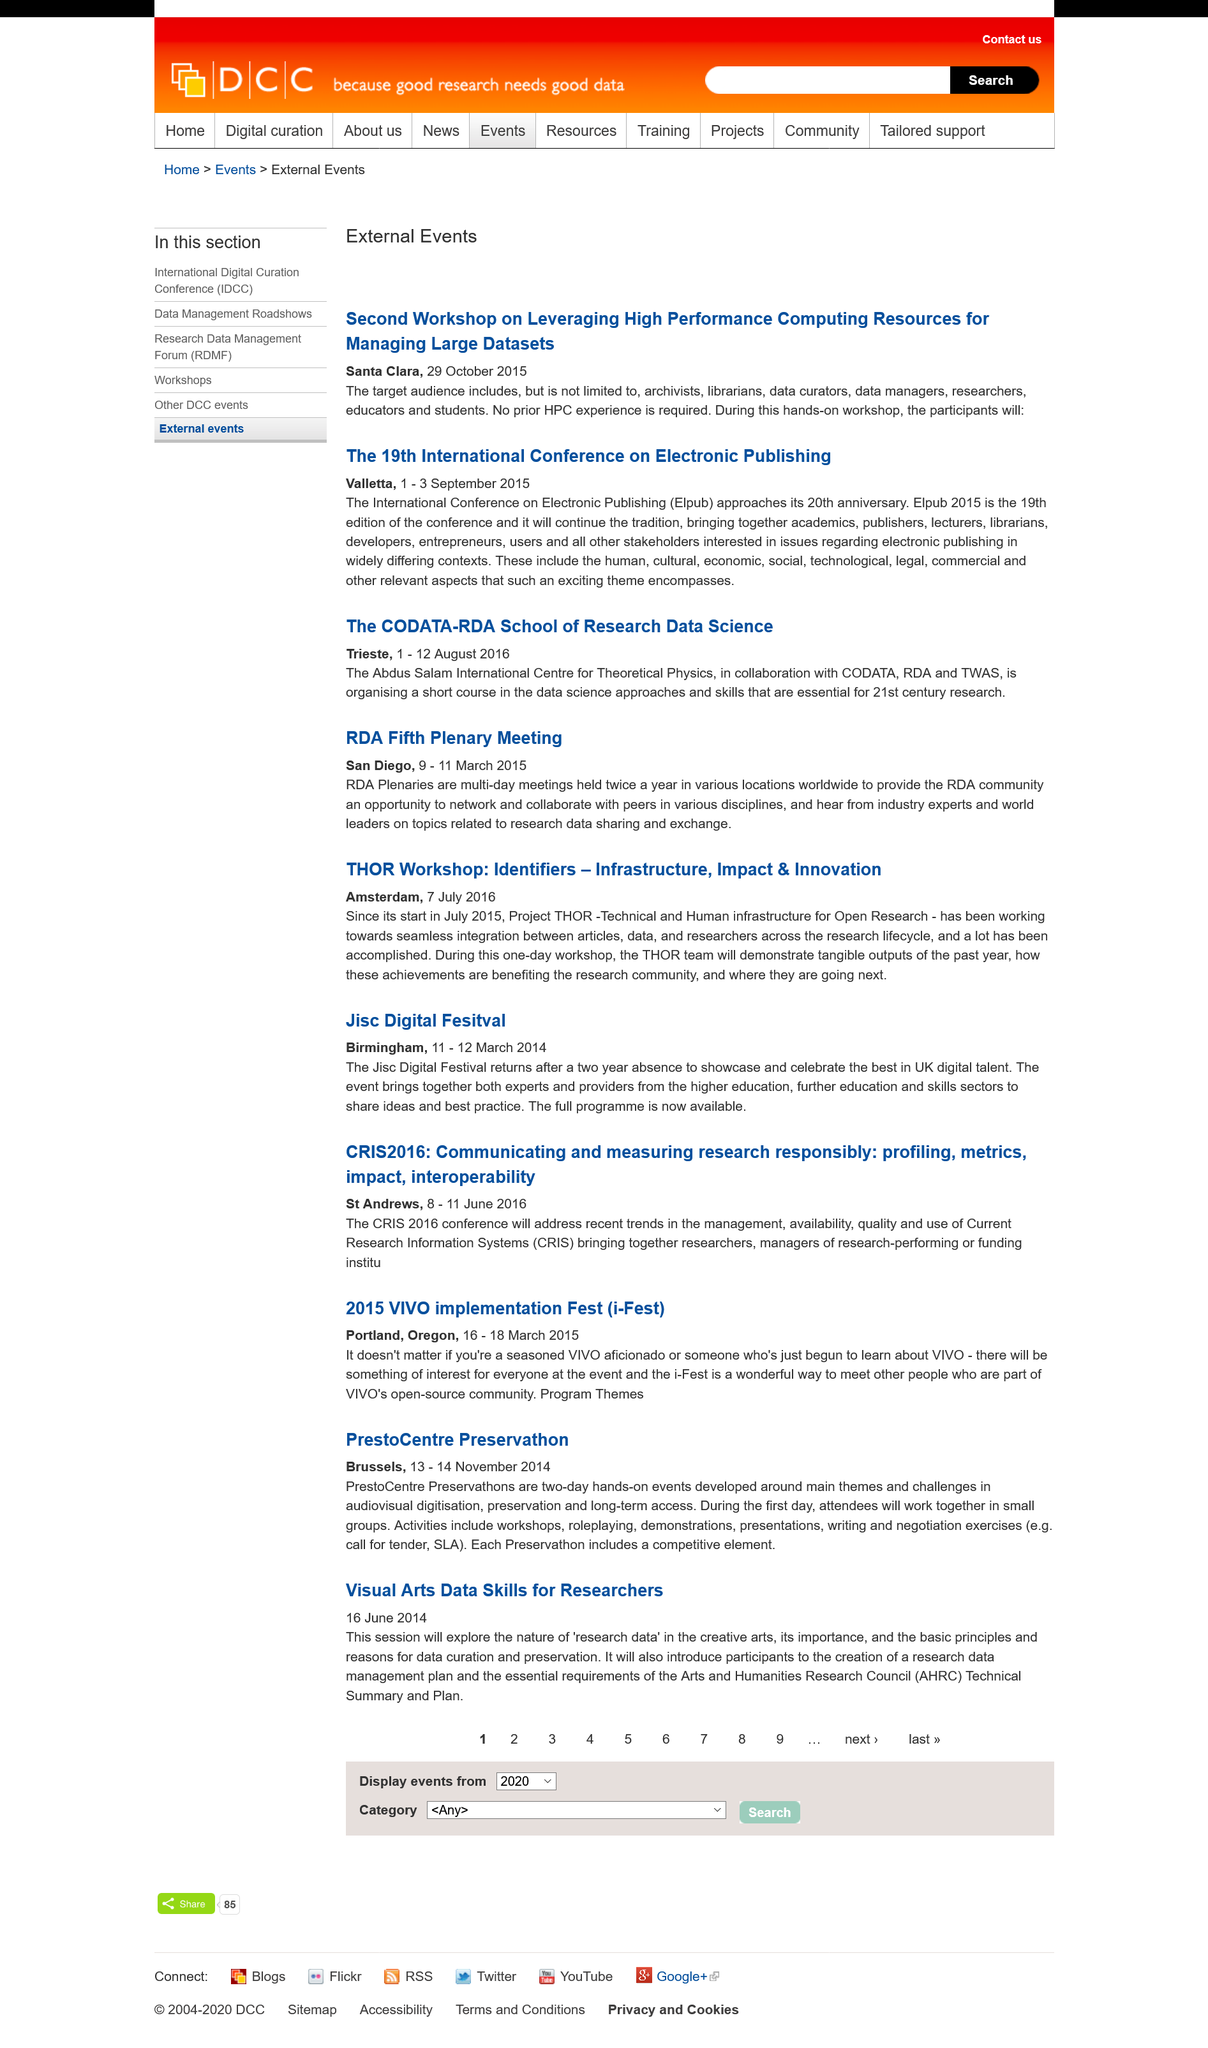Draw attention to some important aspects in this diagram. The 19th International Conference on Electronic Publishing took place in 2015. It is not necessary to have prior experience in High Performance Computing to attend the course 'Leveraging High Performance Computing Resources for Managing Large Datasets'. The target audience for the Second Workshop on "Leveraging High Performance Computing Resources for Managing Large Datasets" includes archivists, librarians, data curators, data managers, researchers, educators, and students. 